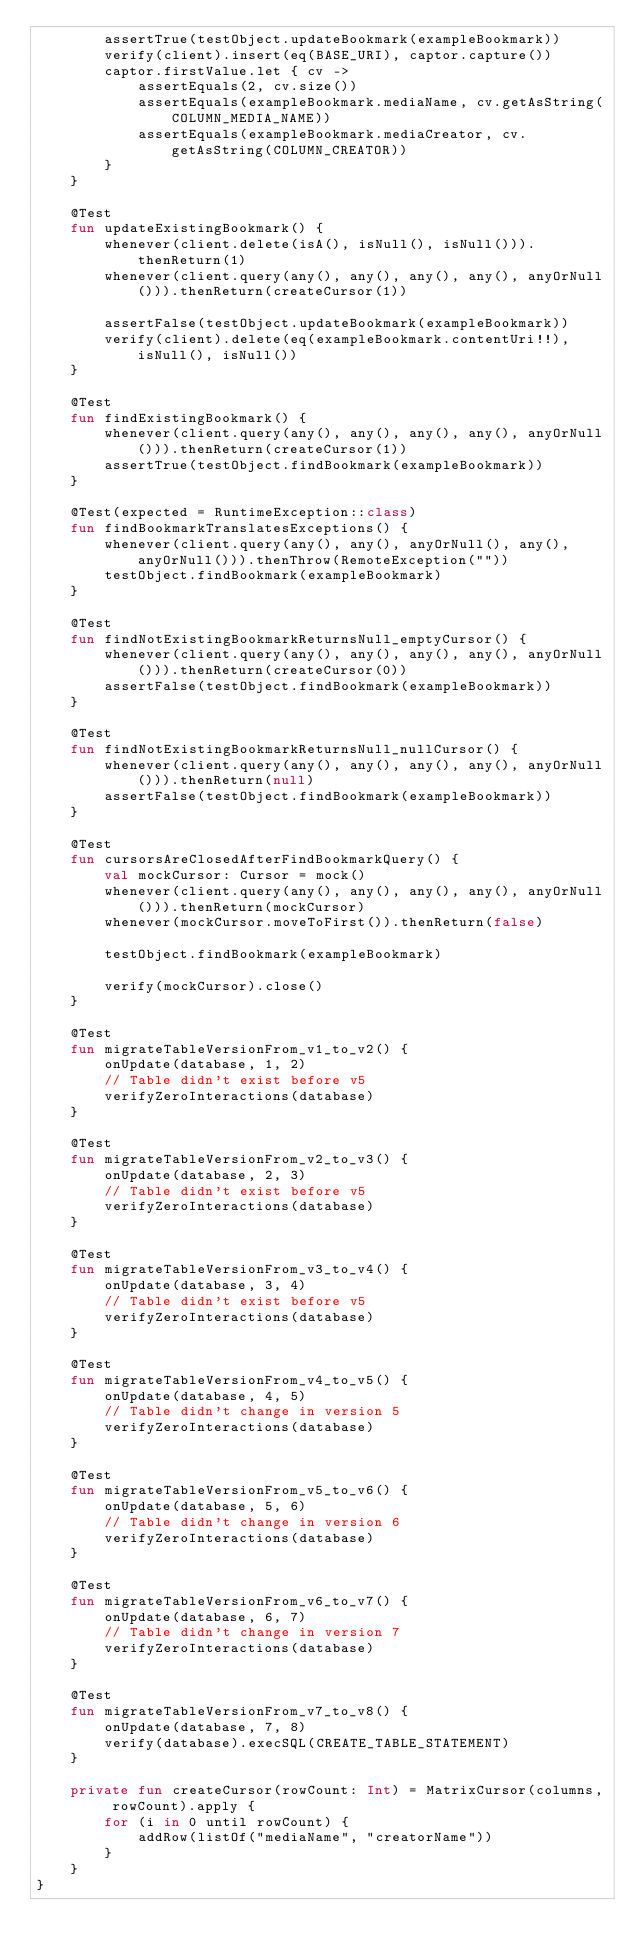Convert code to text. <code><loc_0><loc_0><loc_500><loc_500><_Kotlin_>        assertTrue(testObject.updateBookmark(exampleBookmark))
        verify(client).insert(eq(BASE_URI), captor.capture())
        captor.firstValue.let { cv ->
            assertEquals(2, cv.size())
            assertEquals(exampleBookmark.mediaName, cv.getAsString(COLUMN_MEDIA_NAME))
            assertEquals(exampleBookmark.mediaCreator, cv.getAsString(COLUMN_CREATOR))
        }
    }

    @Test
    fun updateExistingBookmark() {
        whenever(client.delete(isA(), isNull(), isNull())).thenReturn(1)
        whenever(client.query(any(), any(), any(), any(), anyOrNull())).thenReturn(createCursor(1))

        assertFalse(testObject.updateBookmark(exampleBookmark))
        verify(client).delete(eq(exampleBookmark.contentUri!!), isNull(), isNull())
    }

    @Test
    fun findExistingBookmark() {
        whenever(client.query(any(), any(), any(), any(), anyOrNull())).thenReturn(createCursor(1))
        assertTrue(testObject.findBookmark(exampleBookmark))
    }

    @Test(expected = RuntimeException::class)
    fun findBookmarkTranslatesExceptions() {
        whenever(client.query(any(), any(), anyOrNull(), any(), anyOrNull())).thenThrow(RemoteException(""))
        testObject.findBookmark(exampleBookmark)
    }

    @Test
    fun findNotExistingBookmarkReturnsNull_emptyCursor() {
        whenever(client.query(any(), any(), any(), any(), anyOrNull())).thenReturn(createCursor(0))
        assertFalse(testObject.findBookmark(exampleBookmark))
    }

    @Test
    fun findNotExistingBookmarkReturnsNull_nullCursor() {
        whenever(client.query(any(), any(), any(), any(), anyOrNull())).thenReturn(null)
        assertFalse(testObject.findBookmark(exampleBookmark))
    }

    @Test
    fun cursorsAreClosedAfterFindBookmarkQuery() {
        val mockCursor: Cursor = mock()
        whenever(client.query(any(), any(), any(), any(), anyOrNull())).thenReturn(mockCursor)
        whenever(mockCursor.moveToFirst()).thenReturn(false)

        testObject.findBookmark(exampleBookmark)

        verify(mockCursor).close()
    }

    @Test
    fun migrateTableVersionFrom_v1_to_v2() {
        onUpdate(database, 1, 2)
        // Table didn't exist before v5
        verifyZeroInteractions(database)
    }

    @Test
    fun migrateTableVersionFrom_v2_to_v3() {
        onUpdate(database, 2, 3)
        // Table didn't exist before v5
        verifyZeroInteractions(database)
    }

    @Test
    fun migrateTableVersionFrom_v3_to_v4() {
        onUpdate(database, 3, 4)
        // Table didn't exist before v5
        verifyZeroInteractions(database)
    }

    @Test
    fun migrateTableVersionFrom_v4_to_v5() {
        onUpdate(database, 4, 5)
        // Table didn't change in version 5
        verifyZeroInteractions(database)
    }

    @Test
    fun migrateTableVersionFrom_v5_to_v6() {
        onUpdate(database, 5, 6)
        // Table didn't change in version 6
        verifyZeroInteractions(database)
    }

    @Test
    fun migrateTableVersionFrom_v6_to_v7() {
        onUpdate(database, 6, 7)
        // Table didn't change in version 7
        verifyZeroInteractions(database)
    }

    @Test
    fun migrateTableVersionFrom_v7_to_v8() {
        onUpdate(database, 7, 8)
        verify(database).execSQL(CREATE_TABLE_STATEMENT)
    }

    private fun createCursor(rowCount: Int) = MatrixCursor(columns, rowCount).apply {
        for (i in 0 until rowCount) {
            addRow(listOf("mediaName", "creatorName"))
        }
    }
}</code> 